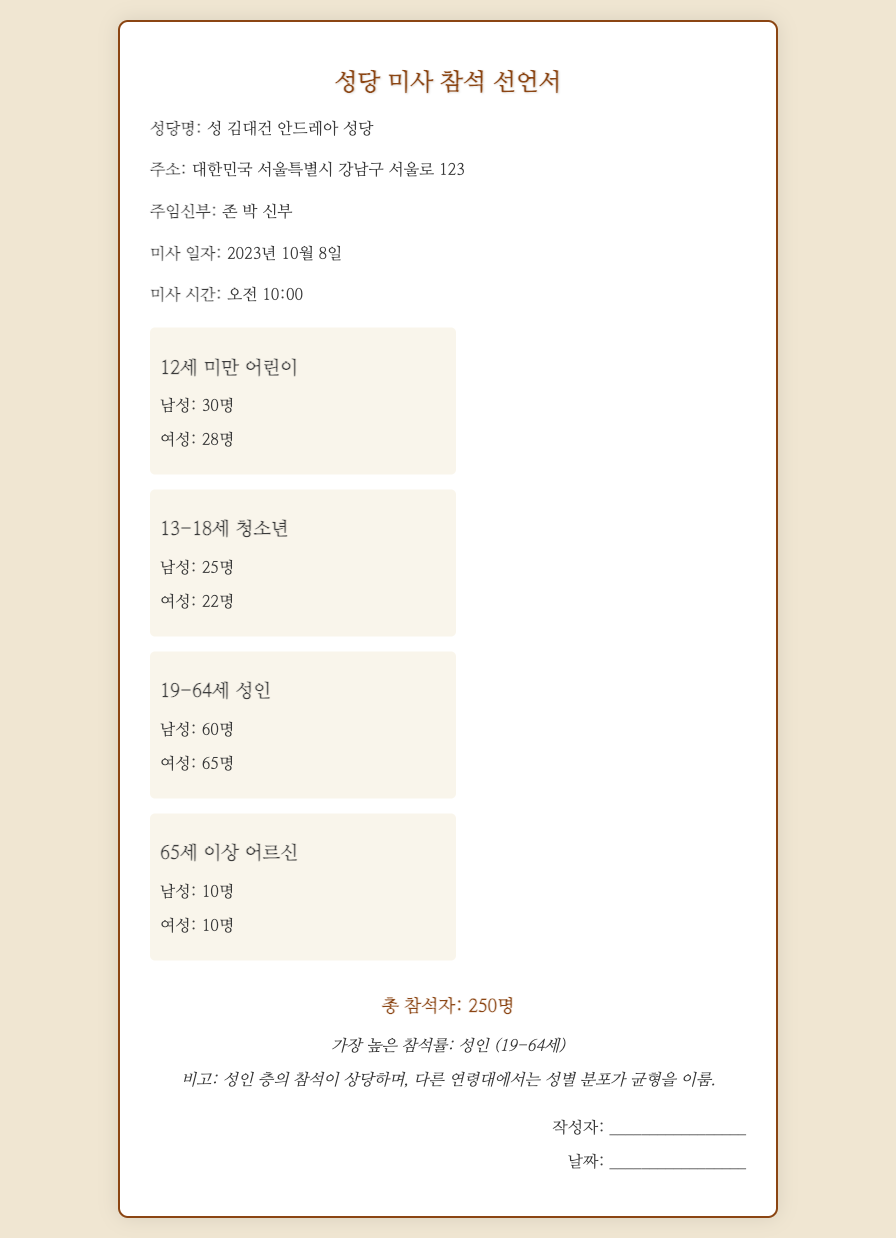What is the name of the church? The name of the church is indicated in the title of the document.
Answer: 성 김대건 안드레아 성당 Who is the priest in charge? The priest in charge is mentioned in the information section of the document.
Answer: 존 박 신부 What is the date of the Mass? The date of the Mass is specified in the document.
Answer: 2023년 10월 8일 How many males attended ages 19-64? The attendance for males aged 19-64 is given in the respective section of attendees.
Answer: 60명 What is the total number of attendees? The total number of attendees is summarized at the end of the document.
Answer: 250명 Which age group has the highest attendance? The document specifies which age group had the highest percentage of attendance.
Answer: 성인 (19-64세) How many females attended ages 12세 미만? The count of females under 12 years old is provided in their section.
Answer: 28명 What is the address of the church? The address is included in the information section of the document.
Answer: 대한민국 서울특별시 강남구 서울로 123 What notable observation is made about the attendance? The observation regarding attendance is detailed in the summary section.
Answer: 성인 층의 참석이 상당하며, 다른 연령대에서는 성별 분포가 균형을 이룸 